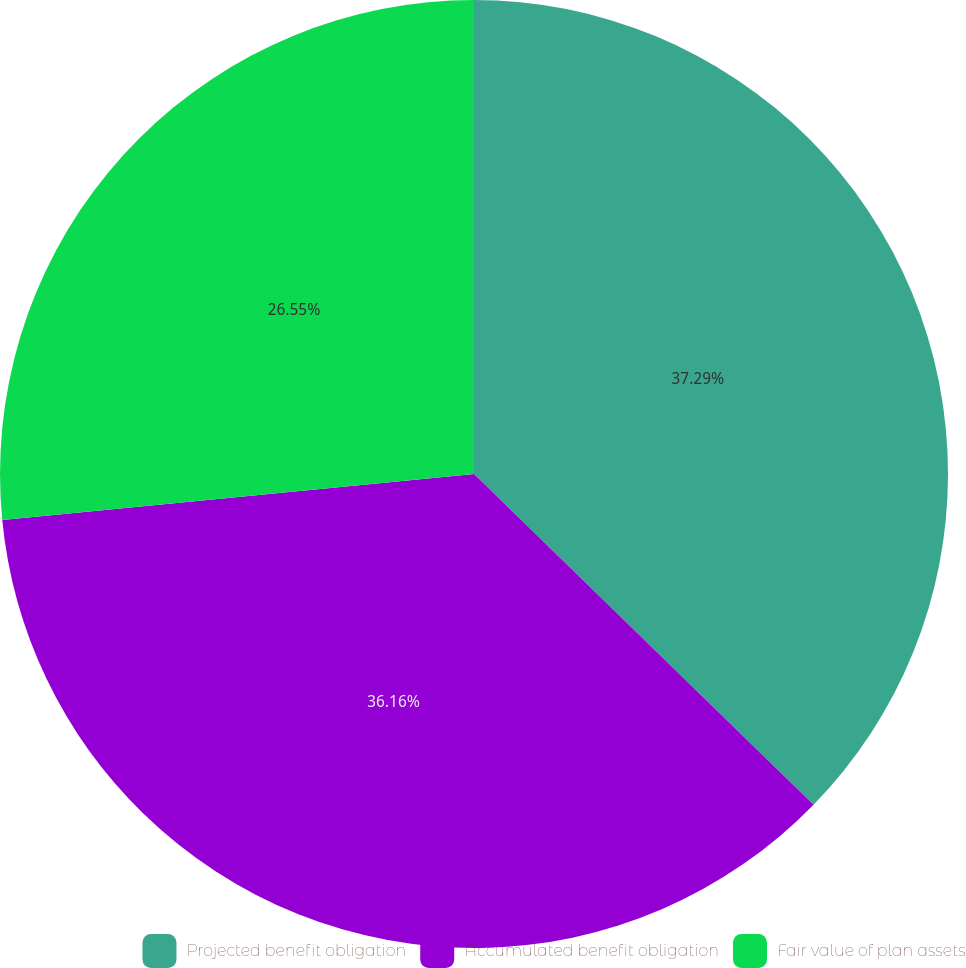<chart> <loc_0><loc_0><loc_500><loc_500><pie_chart><fcel>Projected benefit obligation<fcel>Accumulated benefit obligation<fcel>Fair value of plan assets<nl><fcel>37.29%<fcel>36.16%<fcel>26.55%<nl></chart> 